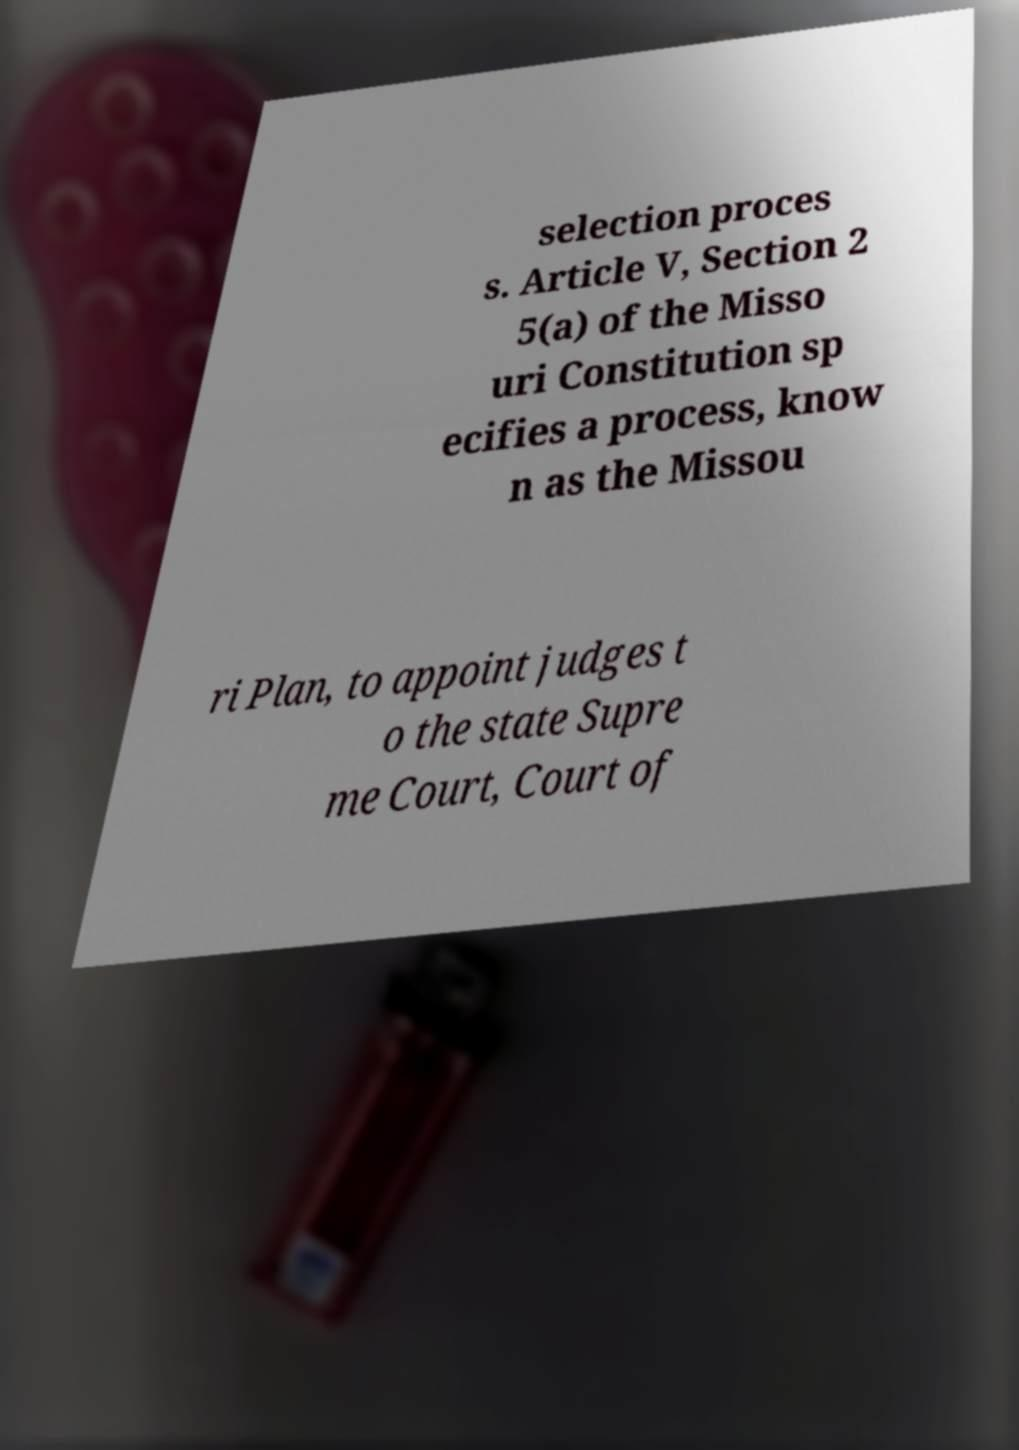Please identify and transcribe the text found in this image. selection proces s. Article V, Section 2 5(a) of the Misso uri Constitution sp ecifies a process, know n as the Missou ri Plan, to appoint judges t o the state Supre me Court, Court of 